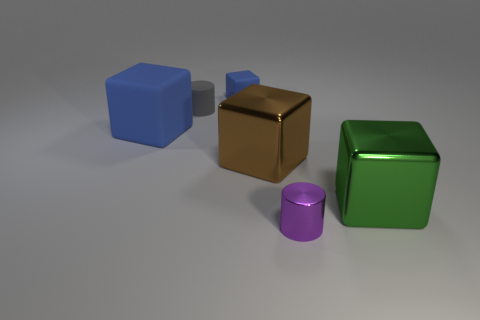Add 3 purple objects. How many objects exist? 9 Subtract all blocks. How many objects are left? 2 Add 5 tiny rubber cylinders. How many tiny rubber cylinders are left? 6 Add 3 metallic cubes. How many metallic cubes exist? 5 Subtract 0 cyan cubes. How many objects are left? 6 Subtract all matte blocks. Subtract all large brown metallic objects. How many objects are left? 3 